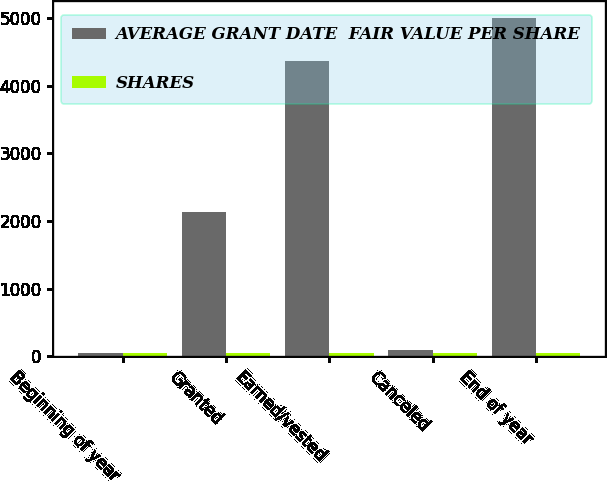Convert chart to OTSL. <chart><loc_0><loc_0><loc_500><loc_500><stacked_bar_chart><ecel><fcel>Beginning of year<fcel>Granted<fcel>Earned/vested<fcel>Canceled<fcel>End of year<nl><fcel>AVERAGE GRANT DATE  FAIR VALUE PER SHARE<fcel>51.91<fcel>2134<fcel>4372<fcel>91<fcel>4999<nl><fcel>SHARES<fcel>49.17<fcel>51.91<fcel>49.14<fcel>51.18<fcel>50.33<nl></chart> 